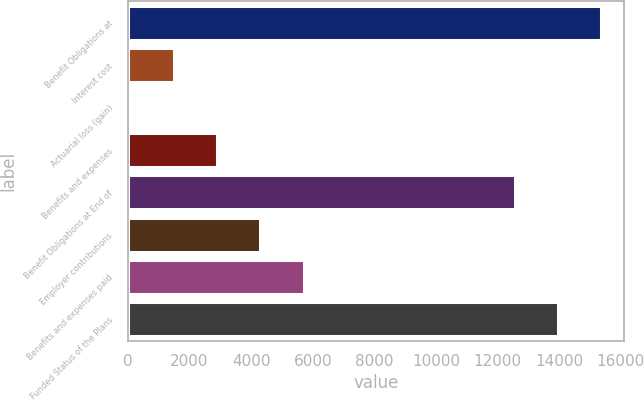Convert chart to OTSL. <chart><loc_0><loc_0><loc_500><loc_500><bar_chart><fcel>Benefit Obligations at<fcel>Interest cost<fcel>Actuarial loss (gain)<fcel>Benefits and expenses<fcel>Benefit Obligations at End of<fcel>Employer contributions<fcel>Benefits and expenses paid<fcel>Funded Status of the Plans<nl><fcel>15349.8<fcel>1505.4<fcel>106<fcel>2904.8<fcel>12551<fcel>4304.2<fcel>5703.6<fcel>13950.4<nl></chart> 